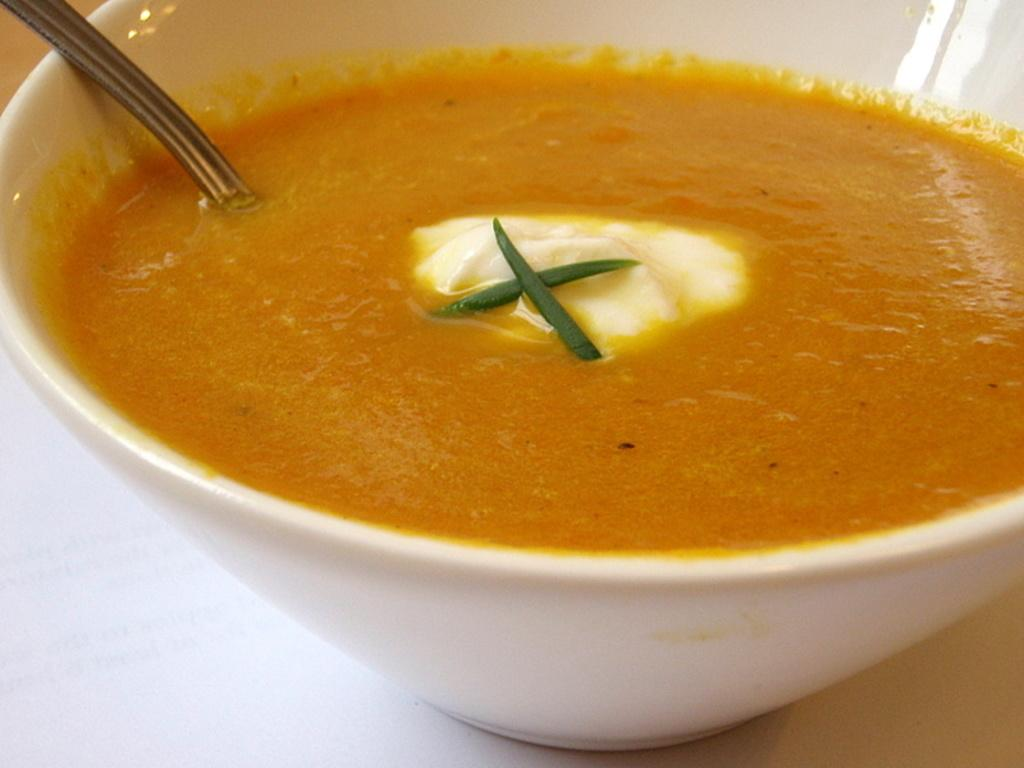What is in the bowl that is visible in the image? There is a bowl with food in the image. What utensil is used with the bowl in the image? There is a spoon in the bowl. What is the color of the surface on which the bowl and spoon are placed? The bowl and spoon are placed on a white surface. What is the tendency of the gate to open and close in the image? There is no gate present in the image, so it is not possible to determine any tendency for it to open or close. 